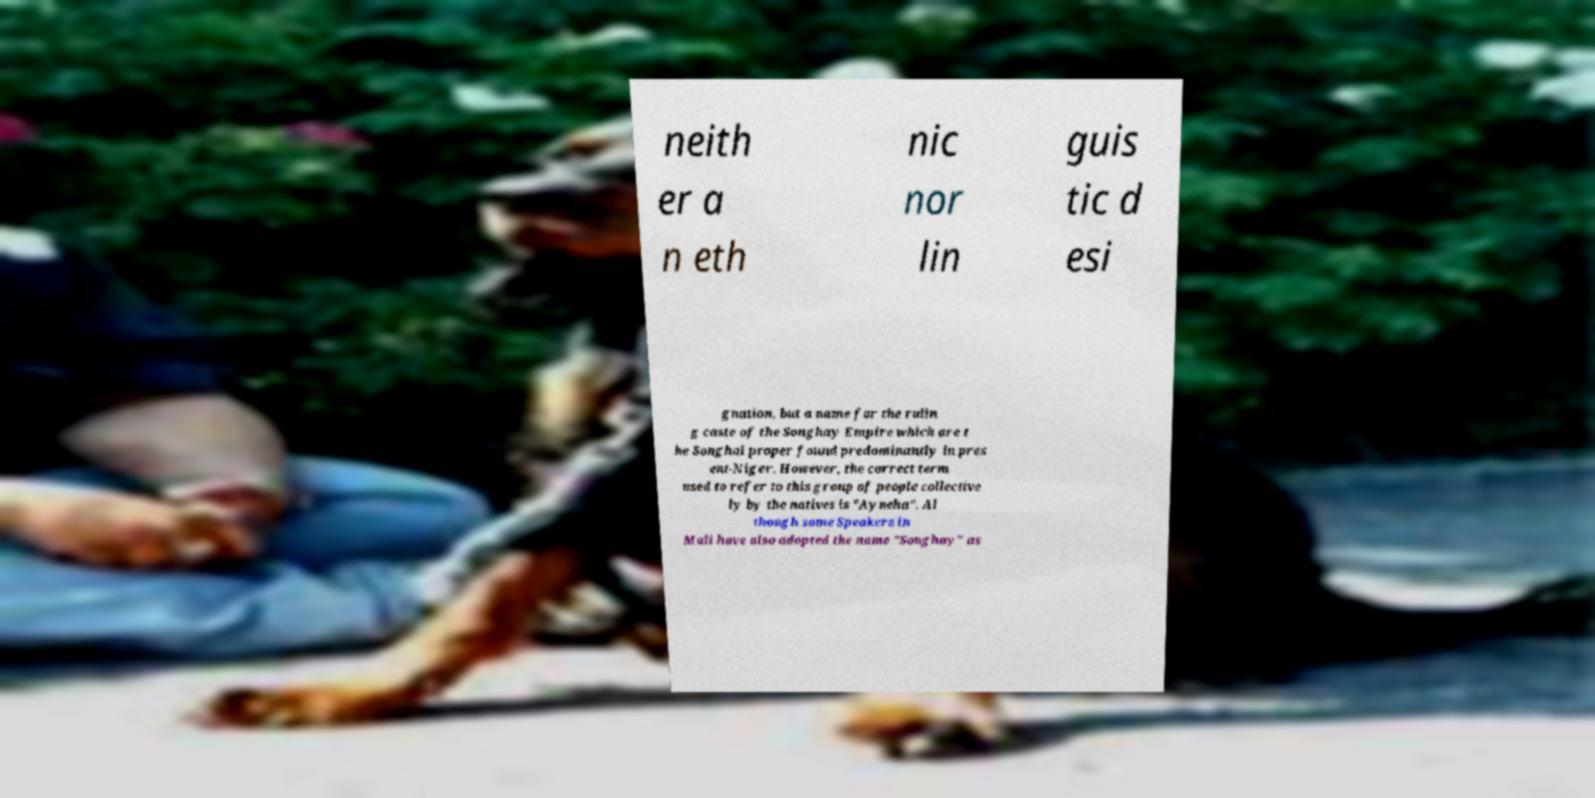Please read and relay the text visible in this image. What does it say? neith er a n eth nic nor lin guis tic d esi gnation, but a name for the rulin g caste of the Songhay Empire which are t he Songhai proper found predominantly in pres ent-Niger. However, the correct term used to refer to this group of people collective ly by the natives is "Ayneha". Al though some Speakers in Mali have also adopted the name "Songhay" as 